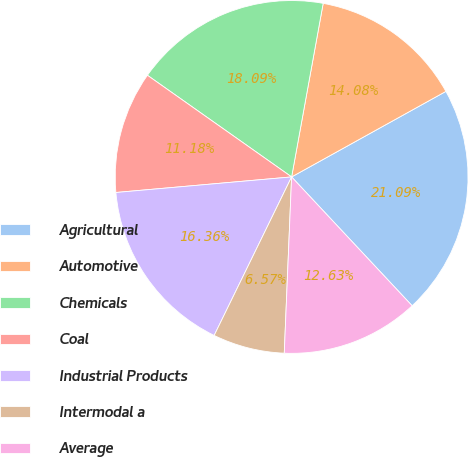Convert chart to OTSL. <chart><loc_0><loc_0><loc_500><loc_500><pie_chart><fcel>Agricultural<fcel>Automotive<fcel>Chemicals<fcel>Coal<fcel>Industrial Products<fcel>Intermodal a<fcel>Average<nl><fcel>21.09%<fcel>14.08%<fcel>18.09%<fcel>11.18%<fcel>16.36%<fcel>6.57%<fcel>12.63%<nl></chart> 